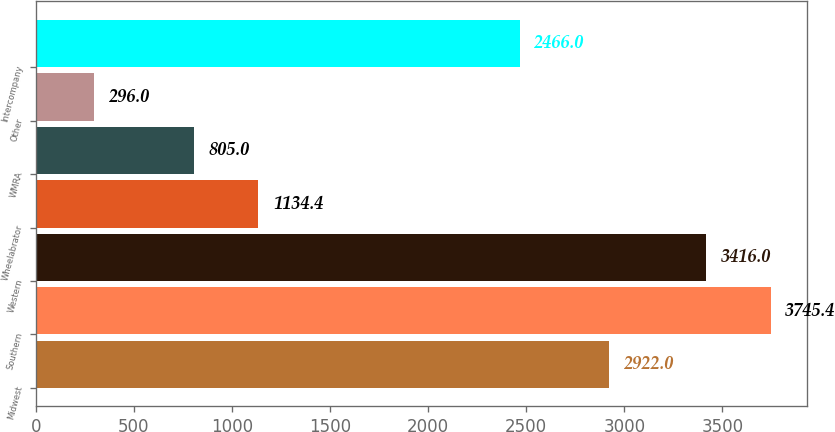Convert chart to OTSL. <chart><loc_0><loc_0><loc_500><loc_500><bar_chart><fcel>Midwest<fcel>Southern<fcel>Western<fcel>Wheelabrator<fcel>WMRA<fcel>Other<fcel>Intercompany<nl><fcel>2922<fcel>3745.4<fcel>3416<fcel>1134.4<fcel>805<fcel>296<fcel>2466<nl></chart> 